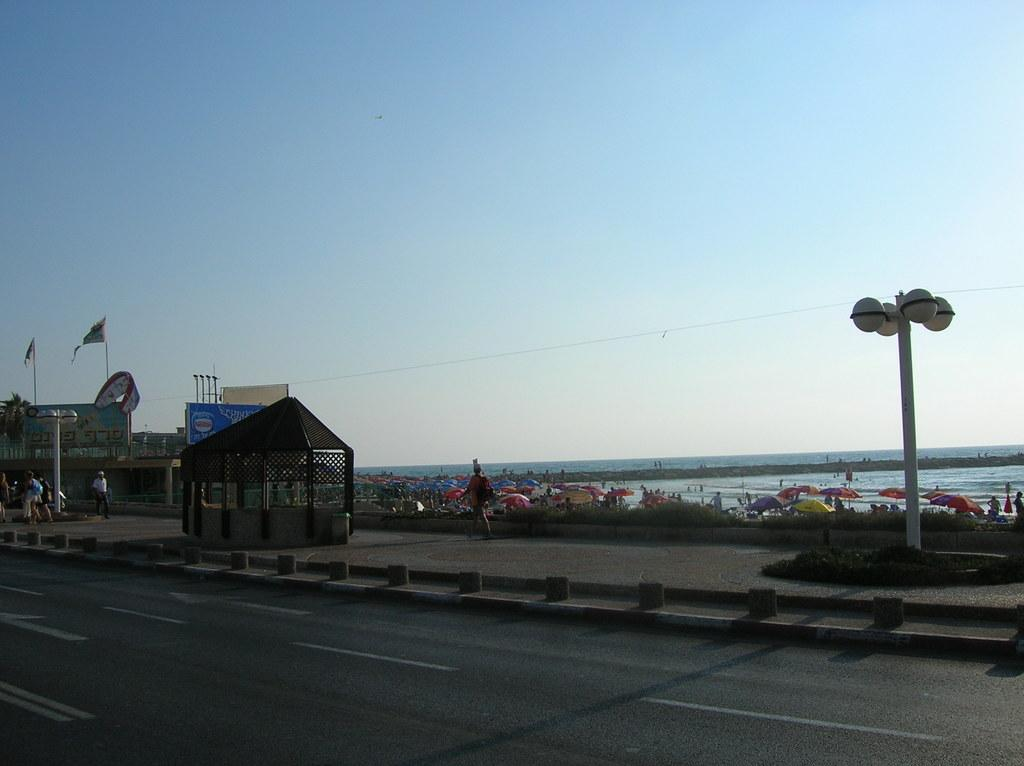What type of structure can be seen in the image? There is a roof with some poles in the image, which suggests a building or similar structure. What natural feature is present in the image? There is a large water body in the image. Can you describe the building in the image? There is a building in the image, but the specific details are not clear from the provided facts. What is attached to the roof in the image? There is a parachute in the image, which is attached to the roof. What is the flag's location in the image? The flag is visible in the image. What type of objects can be seen in the image for protection from the sun or rain? There are umbrellas in the image. What type of architectural elements can be seen in the image? There are street poles in the image. What is the condition of the sky in the image? The sky is visible in the image, but the specific weather conditions are not clear from the provided facts. What type of food is being prepared on the roof in the image? There is no food preparation visible in the image; the main subjects are the roof, poles, water body, building, parachute, flag, umbrellas, street poles, wire, and sky. How does the parachute fold in the image? The parachute does not fold in the image; it is attached to the roof in an open position. 